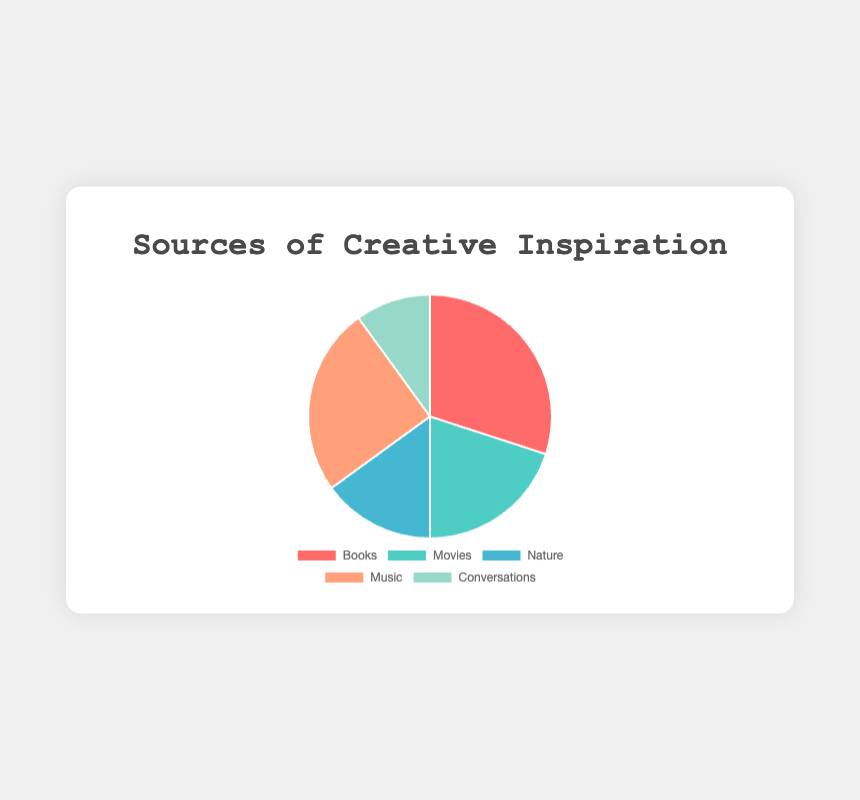What source of inspiration has the highest percentage? From the pie chart, Books have the highest percentage of 30%.
Answer: Books What is the combined percentage of Music and Nature? Music holds 25% and Nature holds 15%. Summing these gives 25% + 15% = 40%.
Answer: 40% Are Conversations more or less popular than Movies as a source of inspiration? Conversations have 10%, while Movies have 20%. Therefore, Conversations are less popular than Movies.
Answer: Less popular Which sources of inspiration have a combined total of 45%? Nature and Music together are 15% + 25% = 40%, and Conversations and Movies together are 10% + 20% = 30%. Books and Nature together are 30% + 15% = 45%.
Answer: Books and Nature Is the percentage of people inspired by Music greater than the percentage of people inspired by Nature and Conversations combined? Music has 25%, Nature has 15%, and Conversations have 10%. Combined, Nature and Conversations add up to 15% + 10% = 25%, which is equal to Music.
Answer: Equal What is the average percentage of the five sources of inspiration? Summing all percentages: 30% (Books) + 20% (Movies) + 15% (Nature) + 25% (Music) + 10% (Conversations) = 100%. The average is 100% / 5 = 20%.
Answer: 20% Which source of inspiration has the least percentage, and what is that percentage? Conversations have the least percentage at 10%.
Answer: Conversations, 10% If you were to group Books and Movies together as "Media," what percentage would this new category represent? Books have 30% and Movies have 20%. Combined, they represent 30% + 20% = 50%.
Answer: 50% If Music's percentage increased by 10%, how would its standing change among all sources? Currently, Music is at 25%. An increase by 10% would make it 35%. This would move it above Books (30%) and become the highest at 35%.
Answer: Highest How much more popular is Books compared to Conversations? Books are at 30% and Conversations are at 10%. The difference is 30% - 10% = 20%.
Answer: 20% more popular 